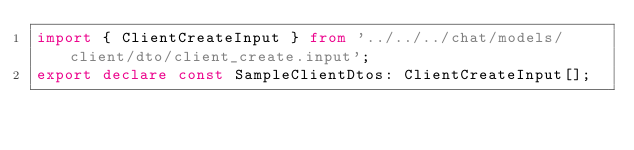Convert code to text. <code><loc_0><loc_0><loc_500><loc_500><_TypeScript_>import { ClientCreateInput } from '../../../chat/models/client/dto/client_create.input';
export declare const SampleClientDtos: ClientCreateInput[];
</code> 